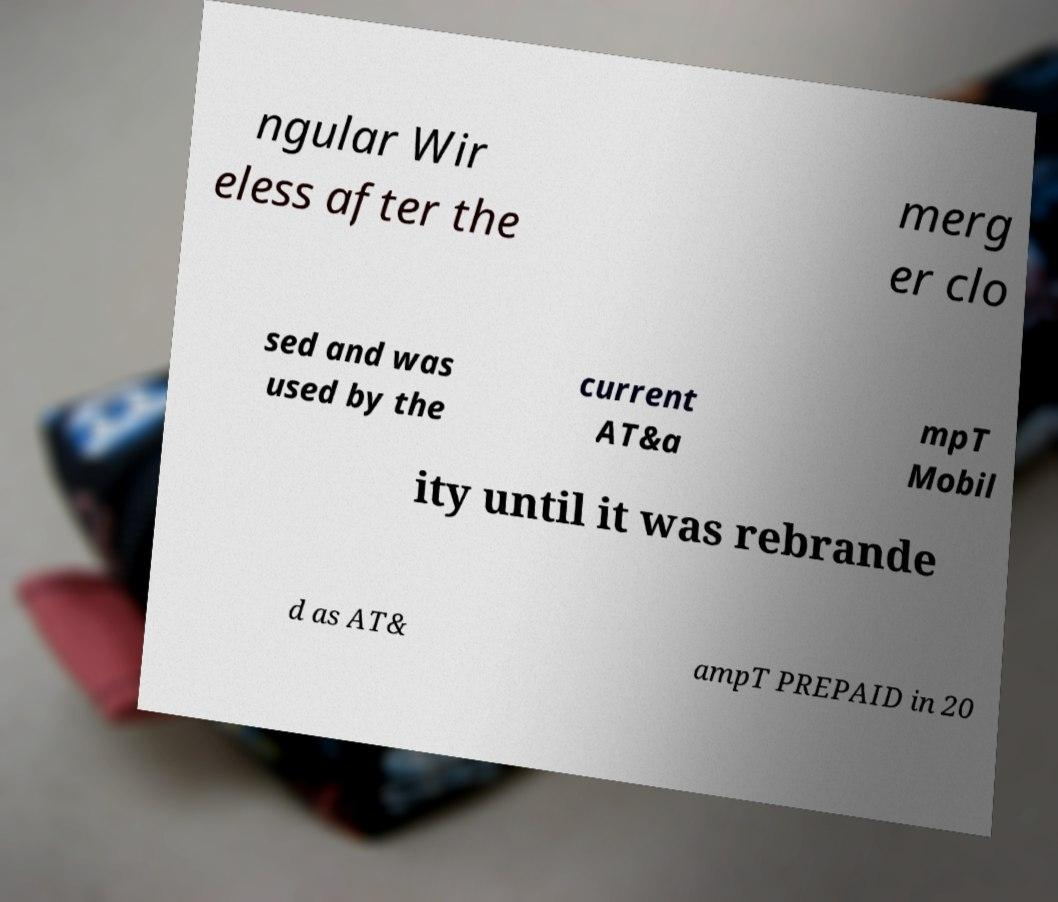There's text embedded in this image that I need extracted. Can you transcribe it verbatim? ngular Wir eless after the merg er clo sed and was used by the current AT&a mpT Mobil ity until it was rebrande d as AT& ampT PREPAID in 20 